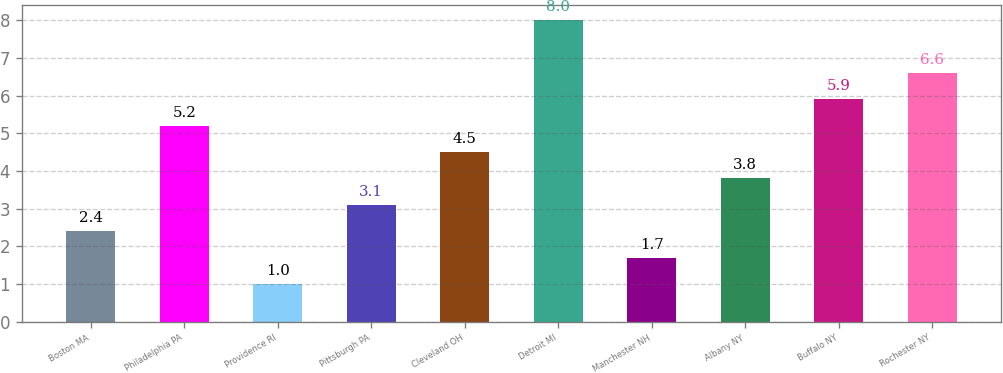Convert chart to OTSL. <chart><loc_0><loc_0><loc_500><loc_500><bar_chart><fcel>Boston MA<fcel>Philadelphia PA<fcel>Providence RI<fcel>Pittsburgh PA<fcel>Cleveland OH<fcel>Detroit MI<fcel>Manchester NH<fcel>Albany NY<fcel>Buffalo NY<fcel>Rochester NY<nl><fcel>2.4<fcel>5.2<fcel>1<fcel>3.1<fcel>4.5<fcel>8<fcel>1.7<fcel>3.8<fcel>5.9<fcel>6.6<nl></chart> 